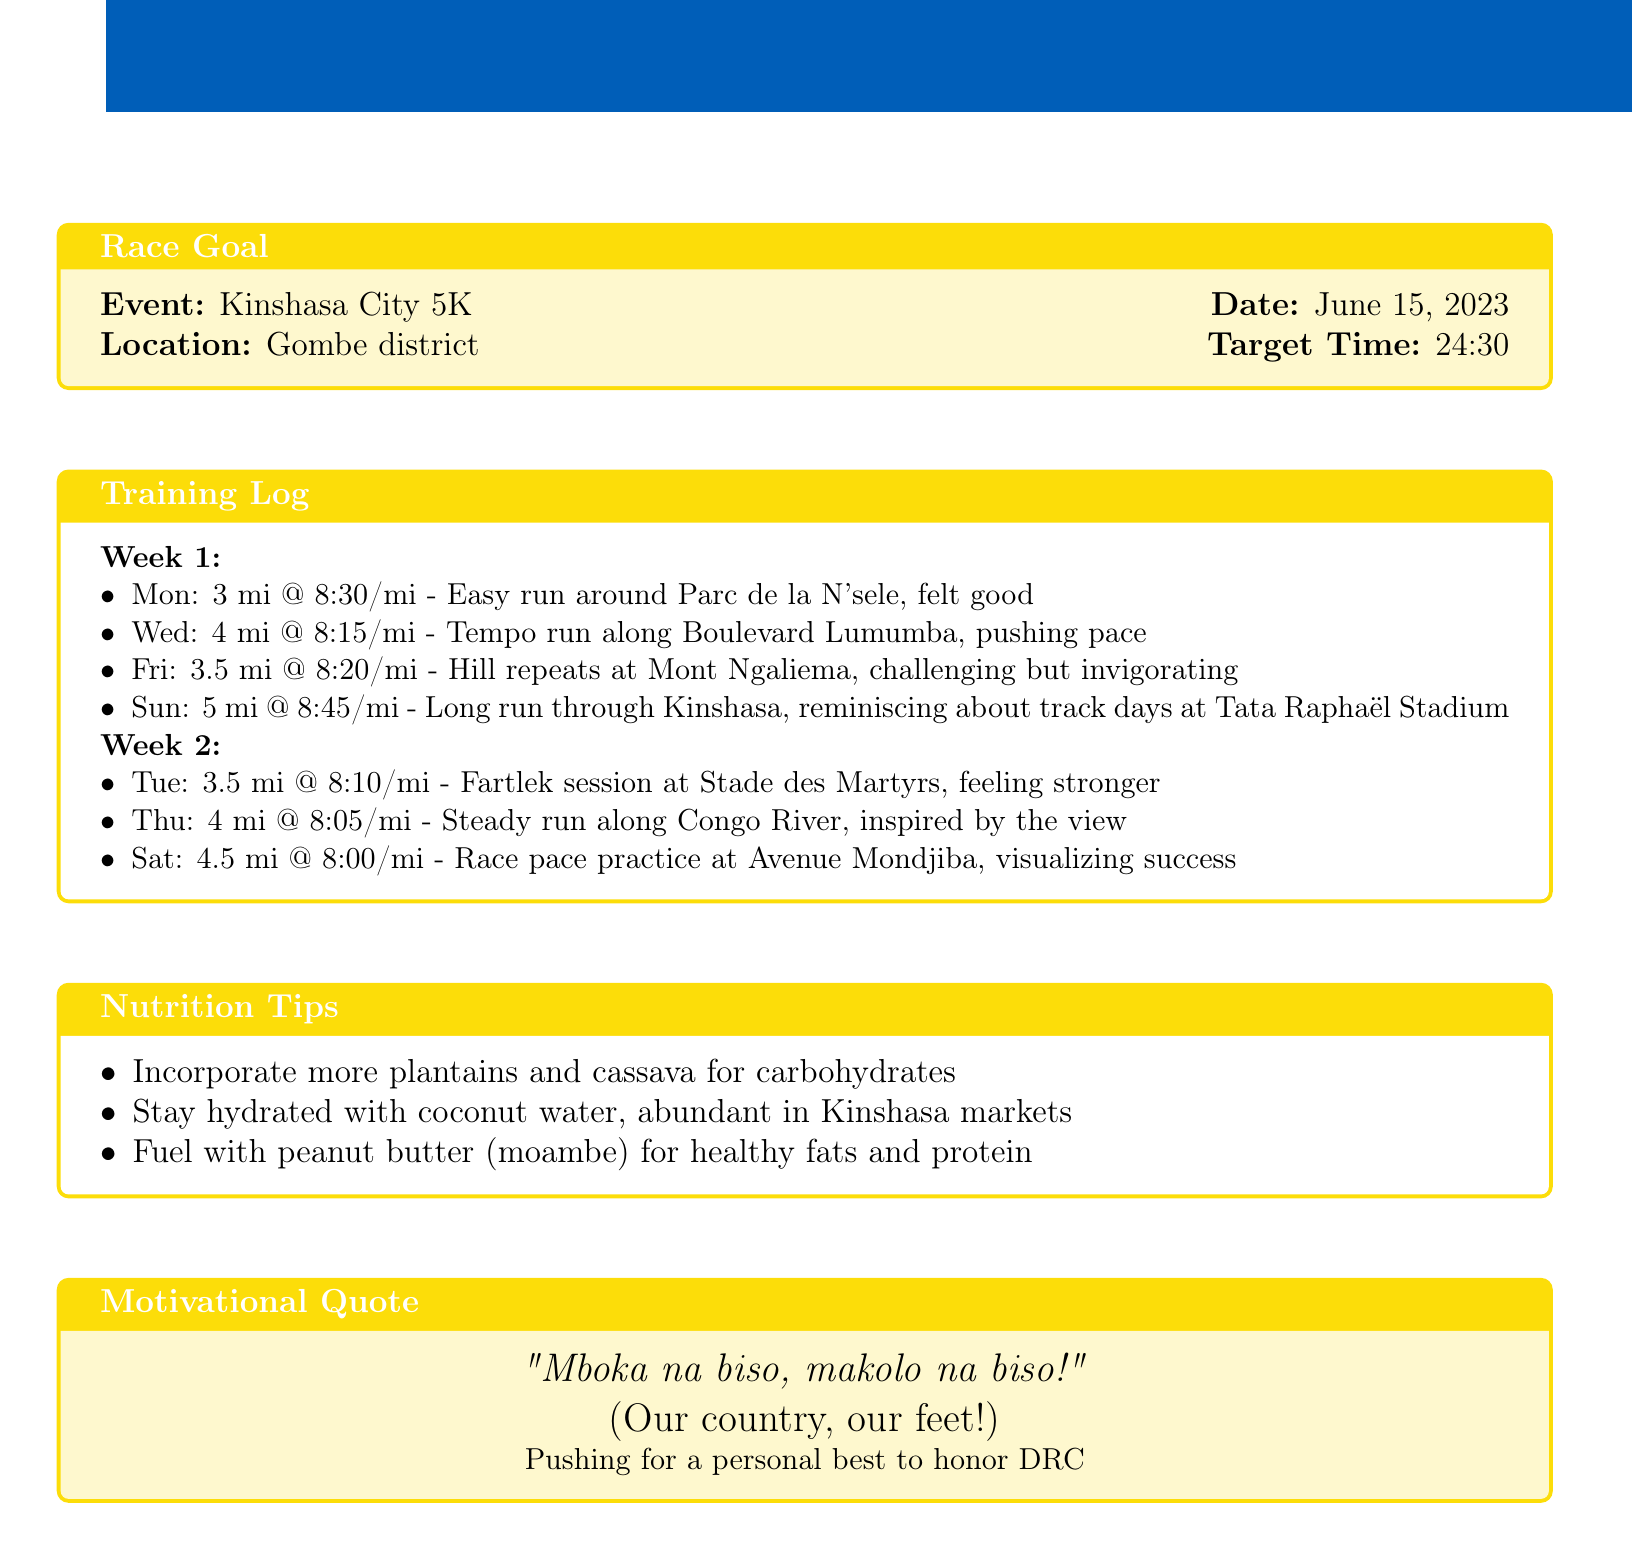What is the target time for the race? The target time for the Kinshasa City 5K is stated as 24:30 in the document.
Answer: 24:30 When is the 5K race scheduled? The date for the Kinshasa City 5K is mentioned as June 15, 2023.
Answer: June 15, 2023 How many miles did you run on the long run day? The mileage for the long run on Sunday in week 1 is noted as 5 miles.
Answer: 5 What was the pace for the tempo run? The document specifies the pace for the tempo run on Wednesday in week 1 as 8:15/mile.
Answer: 8:15/mile Which day was designated for race pace practice? The race pace practice day is indicated as Saturday in week 2.
Answer: Saturday What type of session was held at Stade des Martyrs? The session type mentioned for the day at Stade des Martyrs is a fartlek session.
Answer: Fartlek session What is one nutrition tip provided in the document? The document lists incorporating more plantains and cassava for carbohydrates as one of the nutrition tips.
Answer: Incorporate more plantains and cassava for carbohydrates What motivational quote is included in the log? The document includes the motivational quote "Mboka na biso, makolo na biso!" in the motivational quote section.
Answer: "Mboka na biso, makolo na biso!" How many total entries are there for week 1? The total number of daily entries recorded for week 1 is four as detailed in the training log.
Answer: Four 